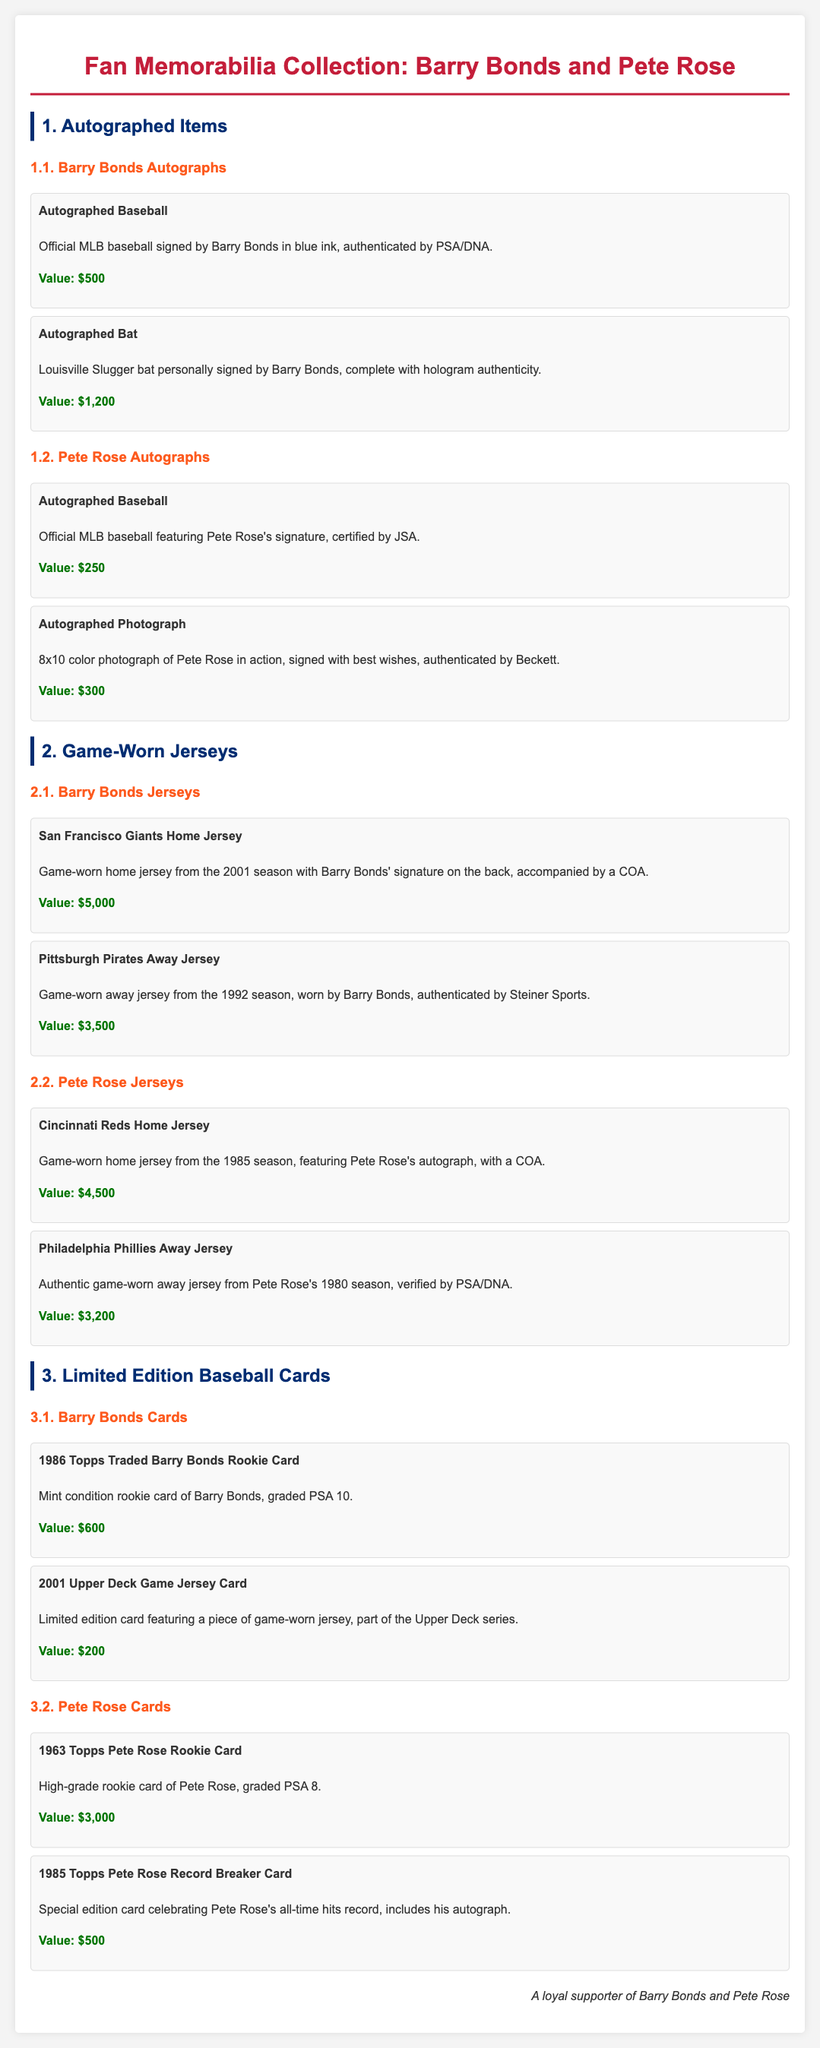What is the value of the autographed baseball signed by Barry Bonds? The document states that the official MLB baseball signed by Barry Bonds has a value of $500.
Answer: $500 What jersey is game-worn from the 2001 season? The game-worn home jersey from the 2001 season is mentioned as having Barry Bonds' signature on the back.
Answer: San Francisco Giants Home Jersey What certification is associated with the autographed photograph of Pete Rose? The photograph is authenticated by Beckett, as stated in the document.
Answer: Beckett How much is the 1985 Topps Pete Rose Record Breaker Card valued at? The value of the special edition card celebrating Pete Rose's all-time hits record is listed as $500.
Answer: $500 Which team wore the away jersey by Barry Bonds from the 1992 season? The document indicates that the away jersey worn by Barry Bonds in the 1992 season is from the Pittsburgh Pirates.
Answer: Pittsburgh Pirates What is the graded value of the 1963 Topps Pete Rose Rookie Card? The high-grade rookie card of Pete Rose is graded PSA 8, as noted in the document.
Answer: PSA 8 What type of memorabilia is the 2001 Upper Deck Game Jersey Card associated with? The document states that it features a piece of a game-worn jersey.
Answer: Game-worn jersey What signature is included with the Cincinnati Reds Home Jersey? The document mentions that the home jersey includes Pete Rose's autograph.
Answer: Pete Rose's autograph 